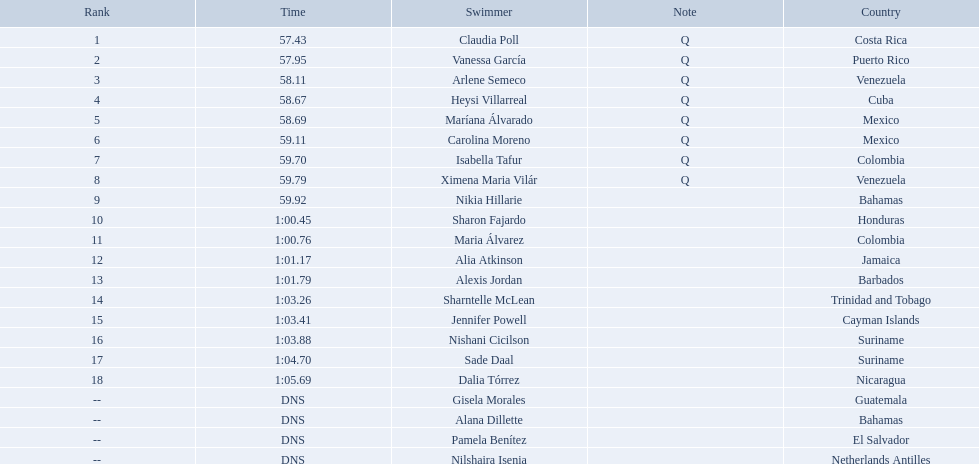Write the full table. {'header': ['Rank', 'Time', 'Swimmer', 'Note', 'Country'], 'rows': [['1', '57.43', 'Claudia Poll', 'Q', 'Costa Rica'], ['2', '57.95', 'Vanessa García', 'Q', 'Puerto Rico'], ['3', '58.11', 'Arlene Semeco', 'Q', 'Venezuela'], ['4', '58.67', 'Heysi Villarreal', 'Q', 'Cuba'], ['5', '58.69', 'Maríana Álvarado', 'Q', 'Mexico'], ['6', '59.11', 'Carolina Moreno', 'Q', 'Mexico'], ['7', '59.70', 'Isabella Tafur', 'Q', 'Colombia'], ['8', '59.79', 'Ximena Maria Vilár', 'Q', 'Venezuela'], ['9', '59.92', 'Nikia Hillarie', '', 'Bahamas'], ['10', '1:00.45', 'Sharon Fajardo', '', 'Honduras'], ['11', '1:00.76', 'Maria Álvarez', '', 'Colombia'], ['12', '1:01.17', 'Alia Atkinson', '', 'Jamaica'], ['13', '1:01.79', 'Alexis Jordan', '', 'Barbados'], ['14', '1:03.26', 'Sharntelle McLean', '', 'Trinidad and Tobago'], ['15', '1:03.41', 'Jennifer Powell', '', 'Cayman Islands'], ['16', '1:03.88', 'Nishani Cicilson', '', 'Suriname'], ['17', '1:04.70', 'Sade Daal', '', 'Suriname'], ['18', '1:05.69', 'Dalia Tórrez', '', 'Nicaragua'], ['--', 'DNS', 'Gisela Morales', '', 'Guatemala'], ['--', 'DNS', 'Alana Dillette', '', 'Bahamas'], ['--', 'DNS', 'Pamela Benítez', '', 'El Salvador'], ['--', 'DNS', 'Nilshaira Isenia', '', 'Netherlands Antilles']]} Where were the top eight finishers from? Costa Rica, Puerto Rico, Venezuela, Cuba, Mexico, Mexico, Colombia, Venezuela. Which of the top eight were from cuba? Heysi Villarreal. Who were all of the swimmers in the women's 100 metre freestyle? Claudia Poll, Vanessa García, Arlene Semeco, Heysi Villarreal, Maríana Álvarado, Carolina Moreno, Isabella Tafur, Ximena Maria Vilár, Nikia Hillarie, Sharon Fajardo, Maria Álvarez, Alia Atkinson, Alexis Jordan, Sharntelle McLean, Jennifer Powell, Nishani Cicilson, Sade Daal, Dalia Tórrez, Gisela Morales, Alana Dillette, Pamela Benítez, Nilshaira Isenia. Where was each swimmer from? Costa Rica, Puerto Rico, Venezuela, Cuba, Mexico, Mexico, Colombia, Venezuela, Bahamas, Honduras, Colombia, Jamaica, Barbados, Trinidad and Tobago, Cayman Islands, Suriname, Suriname, Nicaragua, Guatemala, Bahamas, El Salvador, Netherlands Antilles. What were their ranks? 1, 2, 3, 4, 5, 6, 7, 8, 9, 10, 11, 12, 13, 14, 15, 16, 17, 18, --, --, --, --. Who was in the top eight? Claudia Poll, Vanessa García, Arlene Semeco, Heysi Villarreal, Maríana Álvarado, Carolina Moreno, Isabella Tafur, Ximena Maria Vilár. Parse the full table in json format. {'header': ['Rank', 'Time', 'Swimmer', 'Note', 'Country'], 'rows': [['1', '57.43', 'Claudia Poll', 'Q', 'Costa Rica'], ['2', '57.95', 'Vanessa García', 'Q', 'Puerto Rico'], ['3', '58.11', 'Arlene Semeco', 'Q', 'Venezuela'], ['4', '58.67', 'Heysi Villarreal', 'Q', 'Cuba'], ['5', '58.69', 'Maríana Álvarado', 'Q', 'Mexico'], ['6', '59.11', 'Carolina Moreno', 'Q', 'Mexico'], ['7', '59.70', 'Isabella Tafur', 'Q', 'Colombia'], ['8', '59.79', 'Ximena Maria Vilár', 'Q', 'Venezuela'], ['9', '59.92', 'Nikia Hillarie', '', 'Bahamas'], ['10', '1:00.45', 'Sharon Fajardo', '', 'Honduras'], ['11', '1:00.76', 'Maria Álvarez', '', 'Colombia'], ['12', '1:01.17', 'Alia Atkinson', '', 'Jamaica'], ['13', '1:01.79', 'Alexis Jordan', '', 'Barbados'], ['14', '1:03.26', 'Sharntelle McLean', '', 'Trinidad and Tobago'], ['15', '1:03.41', 'Jennifer Powell', '', 'Cayman Islands'], ['16', '1:03.88', 'Nishani Cicilson', '', 'Suriname'], ['17', '1:04.70', 'Sade Daal', '', 'Suriname'], ['18', '1:05.69', 'Dalia Tórrez', '', 'Nicaragua'], ['--', 'DNS', 'Gisela Morales', '', 'Guatemala'], ['--', 'DNS', 'Alana Dillette', '', 'Bahamas'], ['--', 'DNS', 'Pamela Benítez', '', 'El Salvador'], ['--', 'DNS', 'Nilshaira Isenia', '', 'Netherlands Antilles']]} Of those swimmers, which one was from cuba? Heysi Villarreal. 